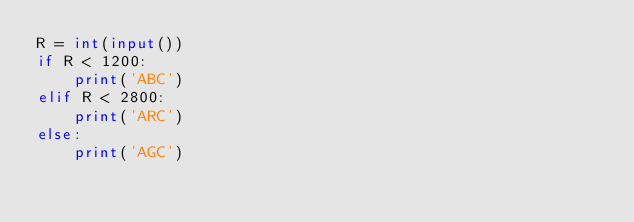Convert code to text. <code><loc_0><loc_0><loc_500><loc_500><_Python_>R = int(input())
if R < 1200:
    print('ABC')
elif R < 2800:
    print('ARC')
else:
    print('AGC')</code> 